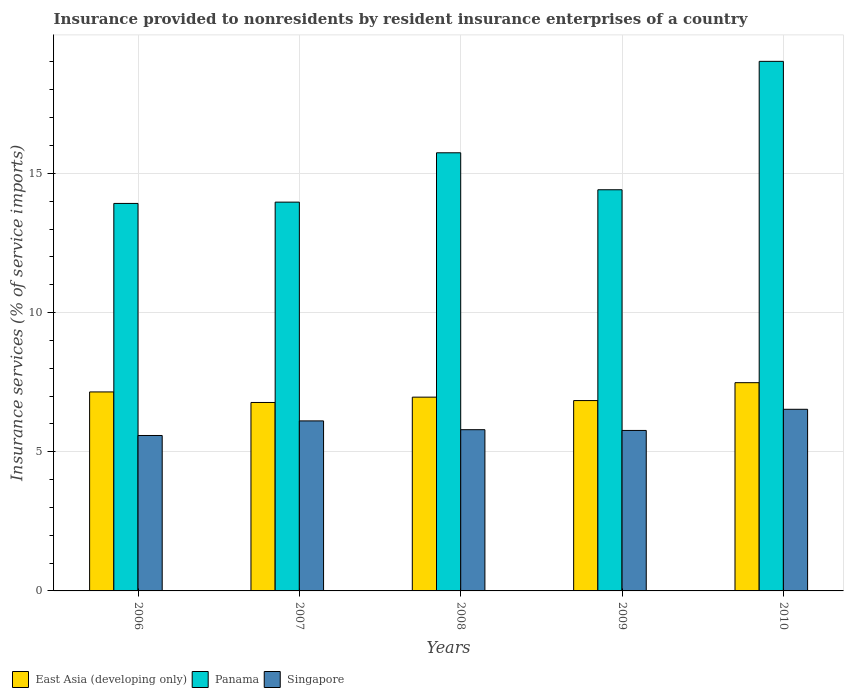How many different coloured bars are there?
Ensure brevity in your answer.  3. How many groups of bars are there?
Provide a succinct answer. 5. Are the number of bars per tick equal to the number of legend labels?
Make the answer very short. Yes. Are the number of bars on each tick of the X-axis equal?
Your response must be concise. Yes. What is the label of the 2nd group of bars from the left?
Provide a succinct answer. 2007. In how many cases, is the number of bars for a given year not equal to the number of legend labels?
Provide a short and direct response. 0. What is the insurance provided to nonresidents in Panama in 2007?
Provide a succinct answer. 13.97. Across all years, what is the maximum insurance provided to nonresidents in Singapore?
Ensure brevity in your answer.  6.52. Across all years, what is the minimum insurance provided to nonresidents in East Asia (developing only)?
Give a very brief answer. 6.77. In which year was the insurance provided to nonresidents in Singapore maximum?
Provide a short and direct response. 2010. In which year was the insurance provided to nonresidents in Panama minimum?
Provide a succinct answer. 2006. What is the total insurance provided to nonresidents in East Asia (developing only) in the graph?
Make the answer very short. 35.2. What is the difference between the insurance provided to nonresidents in Singapore in 2007 and that in 2009?
Ensure brevity in your answer.  0.34. What is the difference between the insurance provided to nonresidents in East Asia (developing only) in 2007 and the insurance provided to nonresidents in Singapore in 2010?
Keep it short and to the point. 0.24. What is the average insurance provided to nonresidents in East Asia (developing only) per year?
Offer a very short reply. 7.04. In the year 2007, what is the difference between the insurance provided to nonresidents in East Asia (developing only) and insurance provided to nonresidents in Panama?
Your answer should be very brief. -7.2. What is the ratio of the insurance provided to nonresidents in East Asia (developing only) in 2008 to that in 2010?
Make the answer very short. 0.93. Is the difference between the insurance provided to nonresidents in East Asia (developing only) in 2007 and 2008 greater than the difference between the insurance provided to nonresidents in Panama in 2007 and 2008?
Give a very brief answer. Yes. What is the difference between the highest and the second highest insurance provided to nonresidents in East Asia (developing only)?
Your answer should be very brief. 0.33. What is the difference between the highest and the lowest insurance provided to nonresidents in Panama?
Ensure brevity in your answer.  5.1. Is the sum of the insurance provided to nonresidents in Singapore in 2006 and 2007 greater than the maximum insurance provided to nonresidents in Panama across all years?
Your answer should be compact. No. What does the 2nd bar from the left in 2006 represents?
Keep it short and to the point. Panama. What does the 1st bar from the right in 2007 represents?
Offer a terse response. Singapore. Is it the case that in every year, the sum of the insurance provided to nonresidents in Panama and insurance provided to nonresidents in Singapore is greater than the insurance provided to nonresidents in East Asia (developing only)?
Give a very brief answer. Yes. How many bars are there?
Make the answer very short. 15. Are all the bars in the graph horizontal?
Your response must be concise. No. How many years are there in the graph?
Offer a very short reply. 5. What is the difference between two consecutive major ticks on the Y-axis?
Provide a succinct answer. 5. Are the values on the major ticks of Y-axis written in scientific E-notation?
Your response must be concise. No. Does the graph contain any zero values?
Make the answer very short. No. Does the graph contain grids?
Your response must be concise. Yes. Where does the legend appear in the graph?
Offer a terse response. Bottom left. How many legend labels are there?
Provide a succinct answer. 3. What is the title of the graph?
Provide a succinct answer. Insurance provided to nonresidents by resident insurance enterprises of a country. Does "Isle of Man" appear as one of the legend labels in the graph?
Make the answer very short. No. What is the label or title of the X-axis?
Your answer should be very brief. Years. What is the label or title of the Y-axis?
Your answer should be very brief. Insurance services (% of service imports). What is the Insurance services (% of service imports) in East Asia (developing only) in 2006?
Provide a succinct answer. 7.15. What is the Insurance services (% of service imports) of Panama in 2006?
Offer a terse response. 13.92. What is the Insurance services (% of service imports) of Singapore in 2006?
Your answer should be compact. 5.58. What is the Insurance services (% of service imports) of East Asia (developing only) in 2007?
Provide a short and direct response. 6.77. What is the Insurance services (% of service imports) of Panama in 2007?
Make the answer very short. 13.97. What is the Insurance services (% of service imports) of Singapore in 2007?
Offer a terse response. 6.11. What is the Insurance services (% of service imports) of East Asia (developing only) in 2008?
Give a very brief answer. 6.96. What is the Insurance services (% of service imports) in Panama in 2008?
Provide a succinct answer. 15.74. What is the Insurance services (% of service imports) in Singapore in 2008?
Make the answer very short. 5.79. What is the Insurance services (% of service imports) in East Asia (developing only) in 2009?
Offer a very short reply. 6.84. What is the Insurance services (% of service imports) in Panama in 2009?
Your answer should be very brief. 14.41. What is the Insurance services (% of service imports) of Singapore in 2009?
Keep it short and to the point. 5.76. What is the Insurance services (% of service imports) in East Asia (developing only) in 2010?
Offer a very short reply. 7.48. What is the Insurance services (% of service imports) of Panama in 2010?
Provide a short and direct response. 19.02. What is the Insurance services (% of service imports) in Singapore in 2010?
Your answer should be very brief. 6.52. Across all years, what is the maximum Insurance services (% of service imports) in East Asia (developing only)?
Provide a short and direct response. 7.48. Across all years, what is the maximum Insurance services (% of service imports) in Panama?
Give a very brief answer. 19.02. Across all years, what is the maximum Insurance services (% of service imports) in Singapore?
Your response must be concise. 6.52. Across all years, what is the minimum Insurance services (% of service imports) in East Asia (developing only)?
Make the answer very short. 6.77. Across all years, what is the minimum Insurance services (% of service imports) in Panama?
Make the answer very short. 13.92. Across all years, what is the minimum Insurance services (% of service imports) of Singapore?
Ensure brevity in your answer.  5.58. What is the total Insurance services (% of service imports) in East Asia (developing only) in the graph?
Offer a very short reply. 35.2. What is the total Insurance services (% of service imports) of Panama in the graph?
Your response must be concise. 77.05. What is the total Insurance services (% of service imports) in Singapore in the graph?
Provide a short and direct response. 29.77. What is the difference between the Insurance services (% of service imports) in East Asia (developing only) in 2006 and that in 2007?
Your response must be concise. 0.38. What is the difference between the Insurance services (% of service imports) in Panama in 2006 and that in 2007?
Keep it short and to the point. -0.05. What is the difference between the Insurance services (% of service imports) of Singapore in 2006 and that in 2007?
Offer a terse response. -0.52. What is the difference between the Insurance services (% of service imports) of East Asia (developing only) in 2006 and that in 2008?
Provide a short and direct response. 0.19. What is the difference between the Insurance services (% of service imports) in Panama in 2006 and that in 2008?
Offer a very short reply. -1.82. What is the difference between the Insurance services (% of service imports) in Singapore in 2006 and that in 2008?
Provide a succinct answer. -0.21. What is the difference between the Insurance services (% of service imports) of East Asia (developing only) in 2006 and that in 2009?
Give a very brief answer. 0.31. What is the difference between the Insurance services (% of service imports) in Panama in 2006 and that in 2009?
Your response must be concise. -0.49. What is the difference between the Insurance services (% of service imports) in Singapore in 2006 and that in 2009?
Provide a succinct answer. -0.18. What is the difference between the Insurance services (% of service imports) of East Asia (developing only) in 2006 and that in 2010?
Offer a very short reply. -0.33. What is the difference between the Insurance services (% of service imports) of Panama in 2006 and that in 2010?
Give a very brief answer. -5.1. What is the difference between the Insurance services (% of service imports) in Singapore in 2006 and that in 2010?
Your response must be concise. -0.94. What is the difference between the Insurance services (% of service imports) in East Asia (developing only) in 2007 and that in 2008?
Your answer should be compact. -0.19. What is the difference between the Insurance services (% of service imports) in Panama in 2007 and that in 2008?
Provide a succinct answer. -1.77. What is the difference between the Insurance services (% of service imports) in Singapore in 2007 and that in 2008?
Keep it short and to the point. 0.32. What is the difference between the Insurance services (% of service imports) in East Asia (developing only) in 2007 and that in 2009?
Provide a succinct answer. -0.07. What is the difference between the Insurance services (% of service imports) in Panama in 2007 and that in 2009?
Your answer should be compact. -0.44. What is the difference between the Insurance services (% of service imports) in Singapore in 2007 and that in 2009?
Offer a terse response. 0.34. What is the difference between the Insurance services (% of service imports) of East Asia (developing only) in 2007 and that in 2010?
Keep it short and to the point. -0.71. What is the difference between the Insurance services (% of service imports) in Panama in 2007 and that in 2010?
Provide a succinct answer. -5.06. What is the difference between the Insurance services (% of service imports) in Singapore in 2007 and that in 2010?
Provide a succinct answer. -0.42. What is the difference between the Insurance services (% of service imports) of East Asia (developing only) in 2008 and that in 2009?
Your answer should be compact. 0.12. What is the difference between the Insurance services (% of service imports) in Panama in 2008 and that in 2009?
Make the answer very short. 1.33. What is the difference between the Insurance services (% of service imports) in Singapore in 2008 and that in 2009?
Offer a terse response. 0.03. What is the difference between the Insurance services (% of service imports) of East Asia (developing only) in 2008 and that in 2010?
Provide a short and direct response. -0.52. What is the difference between the Insurance services (% of service imports) in Panama in 2008 and that in 2010?
Your answer should be very brief. -3.28. What is the difference between the Insurance services (% of service imports) of Singapore in 2008 and that in 2010?
Offer a very short reply. -0.73. What is the difference between the Insurance services (% of service imports) in East Asia (developing only) in 2009 and that in 2010?
Your response must be concise. -0.64. What is the difference between the Insurance services (% of service imports) in Panama in 2009 and that in 2010?
Keep it short and to the point. -4.61. What is the difference between the Insurance services (% of service imports) in Singapore in 2009 and that in 2010?
Make the answer very short. -0.76. What is the difference between the Insurance services (% of service imports) of East Asia (developing only) in 2006 and the Insurance services (% of service imports) of Panama in 2007?
Provide a succinct answer. -6.82. What is the difference between the Insurance services (% of service imports) of East Asia (developing only) in 2006 and the Insurance services (% of service imports) of Singapore in 2007?
Provide a succinct answer. 1.04. What is the difference between the Insurance services (% of service imports) in Panama in 2006 and the Insurance services (% of service imports) in Singapore in 2007?
Provide a short and direct response. 7.81. What is the difference between the Insurance services (% of service imports) of East Asia (developing only) in 2006 and the Insurance services (% of service imports) of Panama in 2008?
Offer a terse response. -8.59. What is the difference between the Insurance services (% of service imports) of East Asia (developing only) in 2006 and the Insurance services (% of service imports) of Singapore in 2008?
Provide a succinct answer. 1.36. What is the difference between the Insurance services (% of service imports) of Panama in 2006 and the Insurance services (% of service imports) of Singapore in 2008?
Keep it short and to the point. 8.13. What is the difference between the Insurance services (% of service imports) in East Asia (developing only) in 2006 and the Insurance services (% of service imports) in Panama in 2009?
Ensure brevity in your answer.  -7.26. What is the difference between the Insurance services (% of service imports) of East Asia (developing only) in 2006 and the Insurance services (% of service imports) of Singapore in 2009?
Your answer should be compact. 1.38. What is the difference between the Insurance services (% of service imports) in Panama in 2006 and the Insurance services (% of service imports) in Singapore in 2009?
Your response must be concise. 8.15. What is the difference between the Insurance services (% of service imports) of East Asia (developing only) in 2006 and the Insurance services (% of service imports) of Panama in 2010?
Your answer should be compact. -11.87. What is the difference between the Insurance services (% of service imports) of East Asia (developing only) in 2006 and the Insurance services (% of service imports) of Singapore in 2010?
Offer a very short reply. 0.62. What is the difference between the Insurance services (% of service imports) in Panama in 2006 and the Insurance services (% of service imports) in Singapore in 2010?
Provide a succinct answer. 7.39. What is the difference between the Insurance services (% of service imports) in East Asia (developing only) in 2007 and the Insurance services (% of service imports) in Panama in 2008?
Your answer should be very brief. -8.97. What is the difference between the Insurance services (% of service imports) in East Asia (developing only) in 2007 and the Insurance services (% of service imports) in Singapore in 2008?
Your response must be concise. 0.98. What is the difference between the Insurance services (% of service imports) in Panama in 2007 and the Insurance services (% of service imports) in Singapore in 2008?
Keep it short and to the point. 8.17. What is the difference between the Insurance services (% of service imports) of East Asia (developing only) in 2007 and the Insurance services (% of service imports) of Panama in 2009?
Your answer should be compact. -7.64. What is the difference between the Insurance services (% of service imports) of East Asia (developing only) in 2007 and the Insurance services (% of service imports) of Singapore in 2009?
Give a very brief answer. 1. What is the difference between the Insurance services (% of service imports) of Panama in 2007 and the Insurance services (% of service imports) of Singapore in 2009?
Provide a short and direct response. 8.2. What is the difference between the Insurance services (% of service imports) of East Asia (developing only) in 2007 and the Insurance services (% of service imports) of Panama in 2010?
Make the answer very short. -12.25. What is the difference between the Insurance services (% of service imports) in East Asia (developing only) in 2007 and the Insurance services (% of service imports) in Singapore in 2010?
Provide a succinct answer. 0.24. What is the difference between the Insurance services (% of service imports) of Panama in 2007 and the Insurance services (% of service imports) of Singapore in 2010?
Ensure brevity in your answer.  7.44. What is the difference between the Insurance services (% of service imports) in East Asia (developing only) in 2008 and the Insurance services (% of service imports) in Panama in 2009?
Offer a very short reply. -7.45. What is the difference between the Insurance services (% of service imports) in East Asia (developing only) in 2008 and the Insurance services (% of service imports) in Singapore in 2009?
Your answer should be compact. 1.2. What is the difference between the Insurance services (% of service imports) in Panama in 2008 and the Insurance services (% of service imports) in Singapore in 2009?
Make the answer very short. 9.97. What is the difference between the Insurance services (% of service imports) in East Asia (developing only) in 2008 and the Insurance services (% of service imports) in Panama in 2010?
Provide a succinct answer. -12.06. What is the difference between the Insurance services (% of service imports) in East Asia (developing only) in 2008 and the Insurance services (% of service imports) in Singapore in 2010?
Offer a very short reply. 0.44. What is the difference between the Insurance services (% of service imports) in Panama in 2008 and the Insurance services (% of service imports) in Singapore in 2010?
Your response must be concise. 9.21. What is the difference between the Insurance services (% of service imports) in East Asia (developing only) in 2009 and the Insurance services (% of service imports) in Panama in 2010?
Your response must be concise. -12.18. What is the difference between the Insurance services (% of service imports) of East Asia (developing only) in 2009 and the Insurance services (% of service imports) of Singapore in 2010?
Make the answer very short. 0.31. What is the difference between the Insurance services (% of service imports) in Panama in 2009 and the Insurance services (% of service imports) in Singapore in 2010?
Ensure brevity in your answer.  7.89. What is the average Insurance services (% of service imports) in East Asia (developing only) per year?
Ensure brevity in your answer.  7.04. What is the average Insurance services (% of service imports) in Panama per year?
Provide a short and direct response. 15.41. What is the average Insurance services (% of service imports) in Singapore per year?
Offer a very short reply. 5.95. In the year 2006, what is the difference between the Insurance services (% of service imports) of East Asia (developing only) and Insurance services (% of service imports) of Panama?
Your answer should be very brief. -6.77. In the year 2006, what is the difference between the Insurance services (% of service imports) in East Asia (developing only) and Insurance services (% of service imports) in Singapore?
Keep it short and to the point. 1.56. In the year 2006, what is the difference between the Insurance services (% of service imports) of Panama and Insurance services (% of service imports) of Singapore?
Offer a terse response. 8.34. In the year 2007, what is the difference between the Insurance services (% of service imports) of East Asia (developing only) and Insurance services (% of service imports) of Panama?
Ensure brevity in your answer.  -7.2. In the year 2007, what is the difference between the Insurance services (% of service imports) of East Asia (developing only) and Insurance services (% of service imports) of Singapore?
Your answer should be very brief. 0.66. In the year 2007, what is the difference between the Insurance services (% of service imports) in Panama and Insurance services (% of service imports) in Singapore?
Make the answer very short. 7.86. In the year 2008, what is the difference between the Insurance services (% of service imports) in East Asia (developing only) and Insurance services (% of service imports) in Panama?
Offer a terse response. -8.78. In the year 2008, what is the difference between the Insurance services (% of service imports) in East Asia (developing only) and Insurance services (% of service imports) in Singapore?
Provide a short and direct response. 1.17. In the year 2008, what is the difference between the Insurance services (% of service imports) of Panama and Insurance services (% of service imports) of Singapore?
Provide a succinct answer. 9.95. In the year 2009, what is the difference between the Insurance services (% of service imports) of East Asia (developing only) and Insurance services (% of service imports) of Panama?
Keep it short and to the point. -7.57. In the year 2009, what is the difference between the Insurance services (% of service imports) of East Asia (developing only) and Insurance services (% of service imports) of Singapore?
Offer a terse response. 1.07. In the year 2009, what is the difference between the Insurance services (% of service imports) of Panama and Insurance services (% of service imports) of Singapore?
Your response must be concise. 8.65. In the year 2010, what is the difference between the Insurance services (% of service imports) in East Asia (developing only) and Insurance services (% of service imports) in Panama?
Give a very brief answer. -11.54. In the year 2010, what is the difference between the Insurance services (% of service imports) of East Asia (developing only) and Insurance services (% of service imports) of Singapore?
Keep it short and to the point. 0.96. In the year 2010, what is the difference between the Insurance services (% of service imports) of Panama and Insurance services (% of service imports) of Singapore?
Provide a succinct answer. 12.5. What is the ratio of the Insurance services (% of service imports) of East Asia (developing only) in 2006 to that in 2007?
Your answer should be compact. 1.06. What is the ratio of the Insurance services (% of service imports) in Panama in 2006 to that in 2007?
Provide a succinct answer. 1. What is the ratio of the Insurance services (% of service imports) in Singapore in 2006 to that in 2007?
Make the answer very short. 0.91. What is the ratio of the Insurance services (% of service imports) of East Asia (developing only) in 2006 to that in 2008?
Your answer should be very brief. 1.03. What is the ratio of the Insurance services (% of service imports) in Panama in 2006 to that in 2008?
Ensure brevity in your answer.  0.88. What is the ratio of the Insurance services (% of service imports) of Singapore in 2006 to that in 2008?
Provide a succinct answer. 0.96. What is the ratio of the Insurance services (% of service imports) of East Asia (developing only) in 2006 to that in 2009?
Your answer should be compact. 1.05. What is the ratio of the Insurance services (% of service imports) of Panama in 2006 to that in 2009?
Provide a short and direct response. 0.97. What is the ratio of the Insurance services (% of service imports) in Singapore in 2006 to that in 2009?
Give a very brief answer. 0.97. What is the ratio of the Insurance services (% of service imports) of East Asia (developing only) in 2006 to that in 2010?
Your answer should be compact. 0.96. What is the ratio of the Insurance services (% of service imports) in Panama in 2006 to that in 2010?
Give a very brief answer. 0.73. What is the ratio of the Insurance services (% of service imports) of Singapore in 2006 to that in 2010?
Your answer should be very brief. 0.86. What is the ratio of the Insurance services (% of service imports) in East Asia (developing only) in 2007 to that in 2008?
Offer a very short reply. 0.97. What is the ratio of the Insurance services (% of service imports) in Panama in 2007 to that in 2008?
Your answer should be very brief. 0.89. What is the ratio of the Insurance services (% of service imports) in Singapore in 2007 to that in 2008?
Keep it short and to the point. 1.05. What is the ratio of the Insurance services (% of service imports) in Panama in 2007 to that in 2009?
Offer a very short reply. 0.97. What is the ratio of the Insurance services (% of service imports) in Singapore in 2007 to that in 2009?
Keep it short and to the point. 1.06. What is the ratio of the Insurance services (% of service imports) of East Asia (developing only) in 2007 to that in 2010?
Your answer should be very brief. 0.9. What is the ratio of the Insurance services (% of service imports) of Panama in 2007 to that in 2010?
Keep it short and to the point. 0.73. What is the ratio of the Insurance services (% of service imports) of Singapore in 2007 to that in 2010?
Provide a succinct answer. 0.94. What is the ratio of the Insurance services (% of service imports) in East Asia (developing only) in 2008 to that in 2009?
Your answer should be compact. 1.02. What is the ratio of the Insurance services (% of service imports) in Panama in 2008 to that in 2009?
Give a very brief answer. 1.09. What is the ratio of the Insurance services (% of service imports) in Singapore in 2008 to that in 2009?
Provide a short and direct response. 1. What is the ratio of the Insurance services (% of service imports) in East Asia (developing only) in 2008 to that in 2010?
Your response must be concise. 0.93. What is the ratio of the Insurance services (% of service imports) of Panama in 2008 to that in 2010?
Provide a succinct answer. 0.83. What is the ratio of the Insurance services (% of service imports) in Singapore in 2008 to that in 2010?
Provide a short and direct response. 0.89. What is the ratio of the Insurance services (% of service imports) in East Asia (developing only) in 2009 to that in 2010?
Offer a very short reply. 0.91. What is the ratio of the Insurance services (% of service imports) of Panama in 2009 to that in 2010?
Ensure brevity in your answer.  0.76. What is the ratio of the Insurance services (% of service imports) in Singapore in 2009 to that in 2010?
Keep it short and to the point. 0.88. What is the difference between the highest and the second highest Insurance services (% of service imports) in East Asia (developing only)?
Give a very brief answer. 0.33. What is the difference between the highest and the second highest Insurance services (% of service imports) of Panama?
Ensure brevity in your answer.  3.28. What is the difference between the highest and the second highest Insurance services (% of service imports) in Singapore?
Provide a succinct answer. 0.42. What is the difference between the highest and the lowest Insurance services (% of service imports) in East Asia (developing only)?
Offer a very short reply. 0.71. What is the difference between the highest and the lowest Insurance services (% of service imports) of Panama?
Keep it short and to the point. 5.1. 